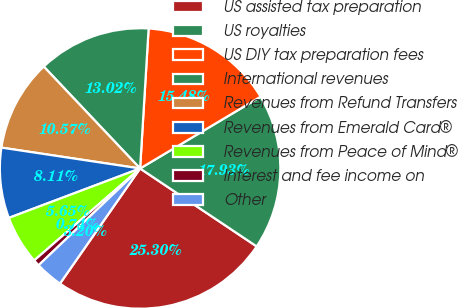<chart> <loc_0><loc_0><loc_500><loc_500><pie_chart><fcel>US assisted tax preparation<fcel>US royalties<fcel>US DIY tax preparation fees<fcel>International revenues<fcel>Revenues from Refund Transfers<fcel>Revenues from Emerald Card®<fcel>Revenues from Peace of Mind®<fcel>Interest and fee income on<fcel>Other<nl><fcel>25.3%<fcel>17.93%<fcel>15.48%<fcel>13.02%<fcel>10.57%<fcel>8.11%<fcel>5.65%<fcel>0.74%<fcel>3.2%<nl></chart> 